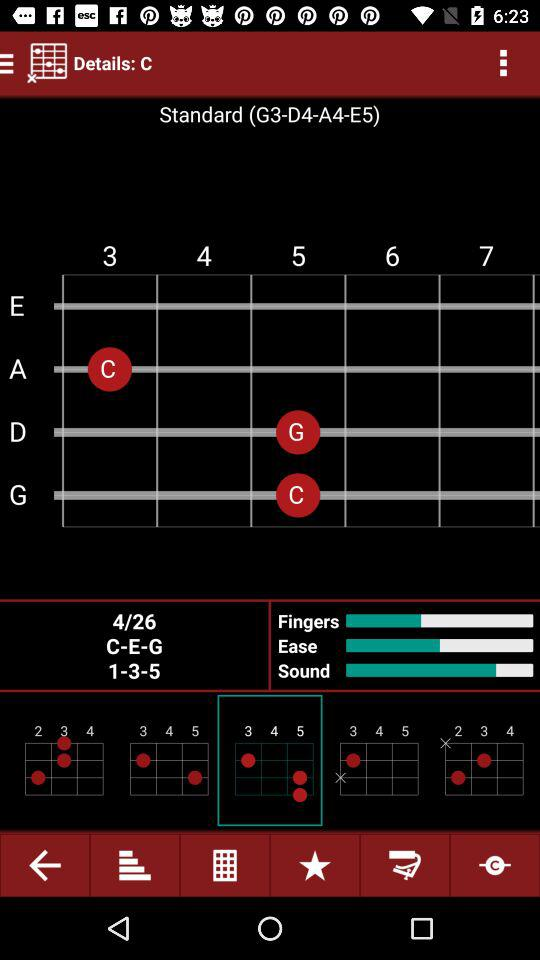What is the standard sequence that has been given there? The standard sequence that has been given is "G3-D4-A4-E5". 